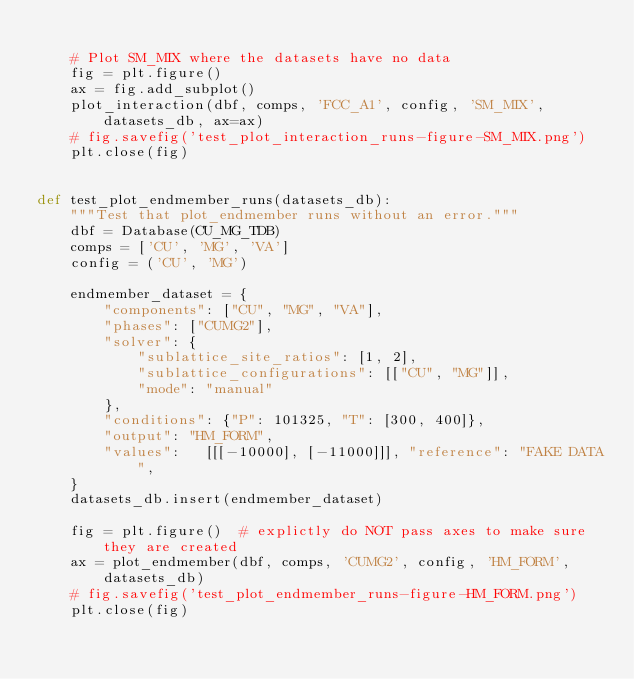Convert code to text. <code><loc_0><loc_0><loc_500><loc_500><_Python_>
    # Plot SM_MIX where the datasets have no data
    fig = plt.figure()
    ax = fig.add_subplot()
    plot_interaction(dbf, comps, 'FCC_A1', config, 'SM_MIX', datasets_db, ax=ax)
    # fig.savefig('test_plot_interaction_runs-figure-SM_MIX.png')
    plt.close(fig)


def test_plot_endmember_runs(datasets_db):
    """Test that plot_endmember runs without an error."""
    dbf = Database(CU_MG_TDB)
    comps = ['CU', 'MG', 'VA']
    config = ('CU', 'MG')

    endmember_dataset = {
        "components": ["CU", "MG", "VA"],
        "phases": ["CUMG2"],
        "solver": {
            "sublattice_site_ratios": [1, 2],
            "sublattice_configurations": [["CU", "MG"]],
            "mode": "manual"
        },
        "conditions": {"P": 101325, "T": [300, 400]},
        "output": "HM_FORM",
        "values":   [[[-10000], [-11000]]], "reference": "FAKE DATA",
    }
    datasets_db.insert(endmember_dataset)

    fig = plt.figure()  # explictly do NOT pass axes to make sure they are created
    ax = plot_endmember(dbf, comps, 'CUMG2', config, 'HM_FORM', datasets_db)
    # fig.savefig('test_plot_endmember_runs-figure-HM_FORM.png')
    plt.close(fig)
</code> 